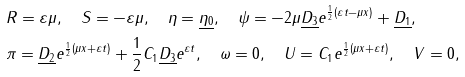Convert formula to latex. <formula><loc_0><loc_0><loc_500><loc_500>& R = \varepsilon \mu , \quad S = - \varepsilon \mu , \quad \eta = \underline { \eta _ { 0 } } , \quad \psi = - 2 \mu \underline { D _ { 3 } } e ^ { \frac { 1 } { 2 } ( \varepsilon t - \mu x ) } + \underline { D _ { 1 } } , \\ & \pi = \underline { D _ { 2 } } e ^ { \frac { 1 } { 2 } ( \mu x + \varepsilon t ) } + \frac { 1 } { 2 } C _ { 1 } \underline { D _ { 3 } } e ^ { \varepsilon t } , \quad \omega = 0 , \quad U = C _ { 1 } e ^ { \frac { 1 } { 2 } ( \mu x + \varepsilon t ) } , \quad V = 0 ,</formula> 